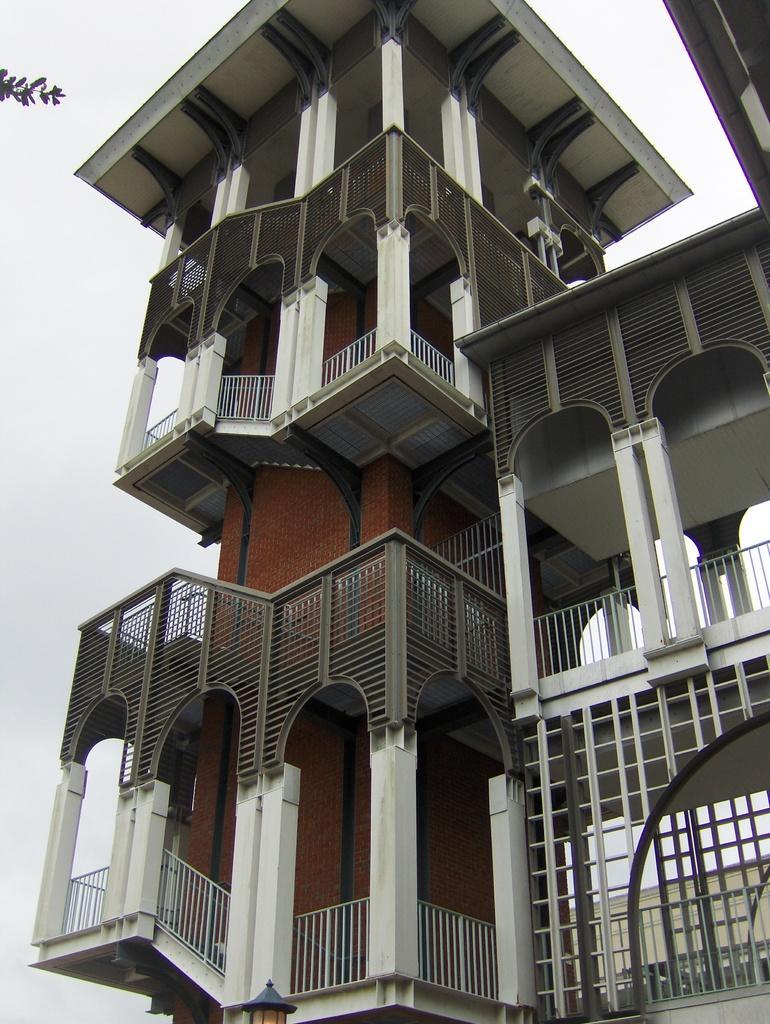Describe this image in one or two sentences. In this picture I can observe a building. This building is in white and brown color. In the background there is a sky. 